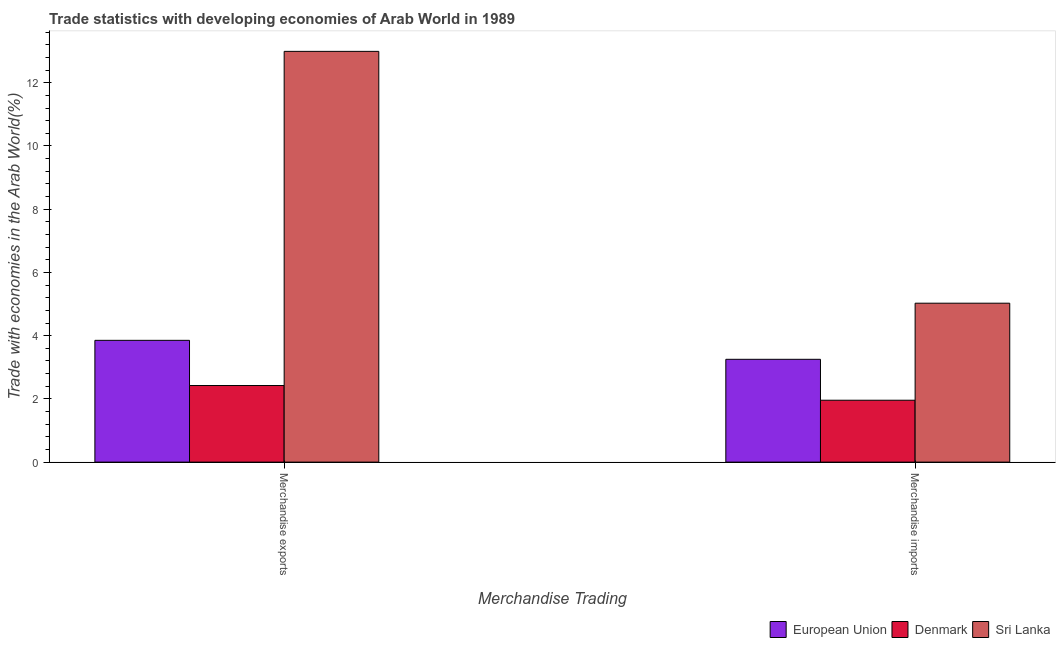How many different coloured bars are there?
Your answer should be very brief. 3. How many groups of bars are there?
Provide a succinct answer. 2. Are the number of bars per tick equal to the number of legend labels?
Provide a succinct answer. Yes. How many bars are there on the 2nd tick from the left?
Ensure brevity in your answer.  3. What is the merchandise exports in Sri Lanka?
Provide a short and direct response. 12.99. Across all countries, what is the maximum merchandise imports?
Keep it short and to the point. 5.03. Across all countries, what is the minimum merchandise imports?
Keep it short and to the point. 1.96. In which country was the merchandise imports maximum?
Make the answer very short. Sri Lanka. In which country was the merchandise imports minimum?
Offer a terse response. Denmark. What is the total merchandise imports in the graph?
Provide a short and direct response. 10.24. What is the difference between the merchandise exports in Denmark and that in Sri Lanka?
Offer a terse response. -10.57. What is the difference between the merchandise exports in Denmark and the merchandise imports in Sri Lanka?
Give a very brief answer. -2.6. What is the average merchandise exports per country?
Your response must be concise. 6.42. What is the difference between the merchandise exports and merchandise imports in Denmark?
Give a very brief answer. 0.47. In how many countries, is the merchandise exports greater than 0.4 %?
Offer a very short reply. 3. What is the ratio of the merchandise exports in Denmark to that in Sri Lanka?
Keep it short and to the point. 0.19. Is the merchandise exports in Denmark less than that in Sri Lanka?
Your response must be concise. Yes. What does the 3rd bar from the left in Merchandise imports represents?
Ensure brevity in your answer.  Sri Lanka. What does the 1st bar from the right in Merchandise imports represents?
Your response must be concise. Sri Lanka. How many bars are there?
Provide a succinct answer. 6. How many countries are there in the graph?
Make the answer very short. 3. Are the values on the major ticks of Y-axis written in scientific E-notation?
Keep it short and to the point. No. Does the graph contain any zero values?
Provide a short and direct response. No. Does the graph contain grids?
Your answer should be compact. No. How are the legend labels stacked?
Ensure brevity in your answer.  Horizontal. What is the title of the graph?
Provide a succinct answer. Trade statistics with developing economies of Arab World in 1989. What is the label or title of the X-axis?
Offer a terse response. Merchandise Trading. What is the label or title of the Y-axis?
Give a very brief answer. Trade with economies in the Arab World(%). What is the Trade with economies in the Arab World(%) of European Union in Merchandise exports?
Your answer should be very brief. 3.85. What is the Trade with economies in the Arab World(%) of Denmark in Merchandise exports?
Offer a very short reply. 2.42. What is the Trade with economies in the Arab World(%) of Sri Lanka in Merchandise exports?
Offer a terse response. 12.99. What is the Trade with economies in the Arab World(%) of European Union in Merchandise imports?
Your answer should be very brief. 3.25. What is the Trade with economies in the Arab World(%) of Denmark in Merchandise imports?
Give a very brief answer. 1.96. What is the Trade with economies in the Arab World(%) of Sri Lanka in Merchandise imports?
Your answer should be very brief. 5.03. Across all Merchandise Trading, what is the maximum Trade with economies in the Arab World(%) of European Union?
Provide a short and direct response. 3.85. Across all Merchandise Trading, what is the maximum Trade with economies in the Arab World(%) of Denmark?
Your answer should be very brief. 2.42. Across all Merchandise Trading, what is the maximum Trade with economies in the Arab World(%) of Sri Lanka?
Make the answer very short. 12.99. Across all Merchandise Trading, what is the minimum Trade with economies in the Arab World(%) of European Union?
Offer a very short reply. 3.25. Across all Merchandise Trading, what is the minimum Trade with economies in the Arab World(%) of Denmark?
Ensure brevity in your answer.  1.96. Across all Merchandise Trading, what is the minimum Trade with economies in the Arab World(%) in Sri Lanka?
Ensure brevity in your answer.  5.03. What is the total Trade with economies in the Arab World(%) in European Union in the graph?
Ensure brevity in your answer.  7.11. What is the total Trade with economies in the Arab World(%) of Denmark in the graph?
Provide a succinct answer. 4.38. What is the total Trade with economies in the Arab World(%) of Sri Lanka in the graph?
Give a very brief answer. 18.02. What is the difference between the Trade with economies in the Arab World(%) in European Union in Merchandise exports and that in Merchandise imports?
Give a very brief answer. 0.6. What is the difference between the Trade with economies in the Arab World(%) in Denmark in Merchandise exports and that in Merchandise imports?
Ensure brevity in your answer.  0.47. What is the difference between the Trade with economies in the Arab World(%) in Sri Lanka in Merchandise exports and that in Merchandise imports?
Your answer should be very brief. 7.97. What is the difference between the Trade with economies in the Arab World(%) of European Union in Merchandise exports and the Trade with economies in the Arab World(%) of Denmark in Merchandise imports?
Give a very brief answer. 1.89. What is the difference between the Trade with economies in the Arab World(%) in European Union in Merchandise exports and the Trade with economies in the Arab World(%) in Sri Lanka in Merchandise imports?
Provide a succinct answer. -1.17. What is the difference between the Trade with economies in the Arab World(%) in Denmark in Merchandise exports and the Trade with economies in the Arab World(%) in Sri Lanka in Merchandise imports?
Keep it short and to the point. -2.6. What is the average Trade with economies in the Arab World(%) of European Union per Merchandise Trading?
Make the answer very short. 3.55. What is the average Trade with economies in the Arab World(%) of Denmark per Merchandise Trading?
Keep it short and to the point. 2.19. What is the average Trade with economies in the Arab World(%) of Sri Lanka per Merchandise Trading?
Ensure brevity in your answer.  9.01. What is the difference between the Trade with economies in the Arab World(%) of European Union and Trade with economies in the Arab World(%) of Denmark in Merchandise exports?
Give a very brief answer. 1.43. What is the difference between the Trade with economies in the Arab World(%) in European Union and Trade with economies in the Arab World(%) in Sri Lanka in Merchandise exports?
Ensure brevity in your answer.  -9.14. What is the difference between the Trade with economies in the Arab World(%) in Denmark and Trade with economies in the Arab World(%) in Sri Lanka in Merchandise exports?
Your response must be concise. -10.57. What is the difference between the Trade with economies in the Arab World(%) of European Union and Trade with economies in the Arab World(%) of Denmark in Merchandise imports?
Your answer should be compact. 1.29. What is the difference between the Trade with economies in the Arab World(%) of European Union and Trade with economies in the Arab World(%) of Sri Lanka in Merchandise imports?
Your answer should be very brief. -1.77. What is the difference between the Trade with economies in the Arab World(%) in Denmark and Trade with economies in the Arab World(%) in Sri Lanka in Merchandise imports?
Give a very brief answer. -3.07. What is the ratio of the Trade with economies in the Arab World(%) in European Union in Merchandise exports to that in Merchandise imports?
Provide a short and direct response. 1.18. What is the ratio of the Trade with economies in the Arab World(%) of Denmark in Merchandise exports to that in Merchandise imports?
Provide a succinct answer. 1.24. What is the ratio of the Trade with economies in the Arab World(%) of Sri Lanka in Merchandise exports to that in Merchandise imports?
Offer a very short reply. 2.58. What is the difference between the highest and the second highest Trade with economies in the Arab World(%) in European Union?
Your answer should be compact. 0.6. What is the difference between the highest and the second highest Trade with economies in the Arab World(%) in Denmark?
Give a very brief answer. 0.47. What is the difference between the highest and the second highest Trade with economies in the Arab World(%) of Sri Lanka?
Give a very brief answer. 7.97. What is the difference between the highest and the lowest Trade with economies in the Arab World(%) in European Union?
Offer a terse response. 0.6. What is the difference between the highest and the lowest Trade with economies in the Arab World(%) in Denmark?
Your response must be concise. 0.47. What is the difference between the highest and the lowest Trade with economies in the Arab World(%) of Sri Lanka?
Your answer should be very brief. 7.97. 